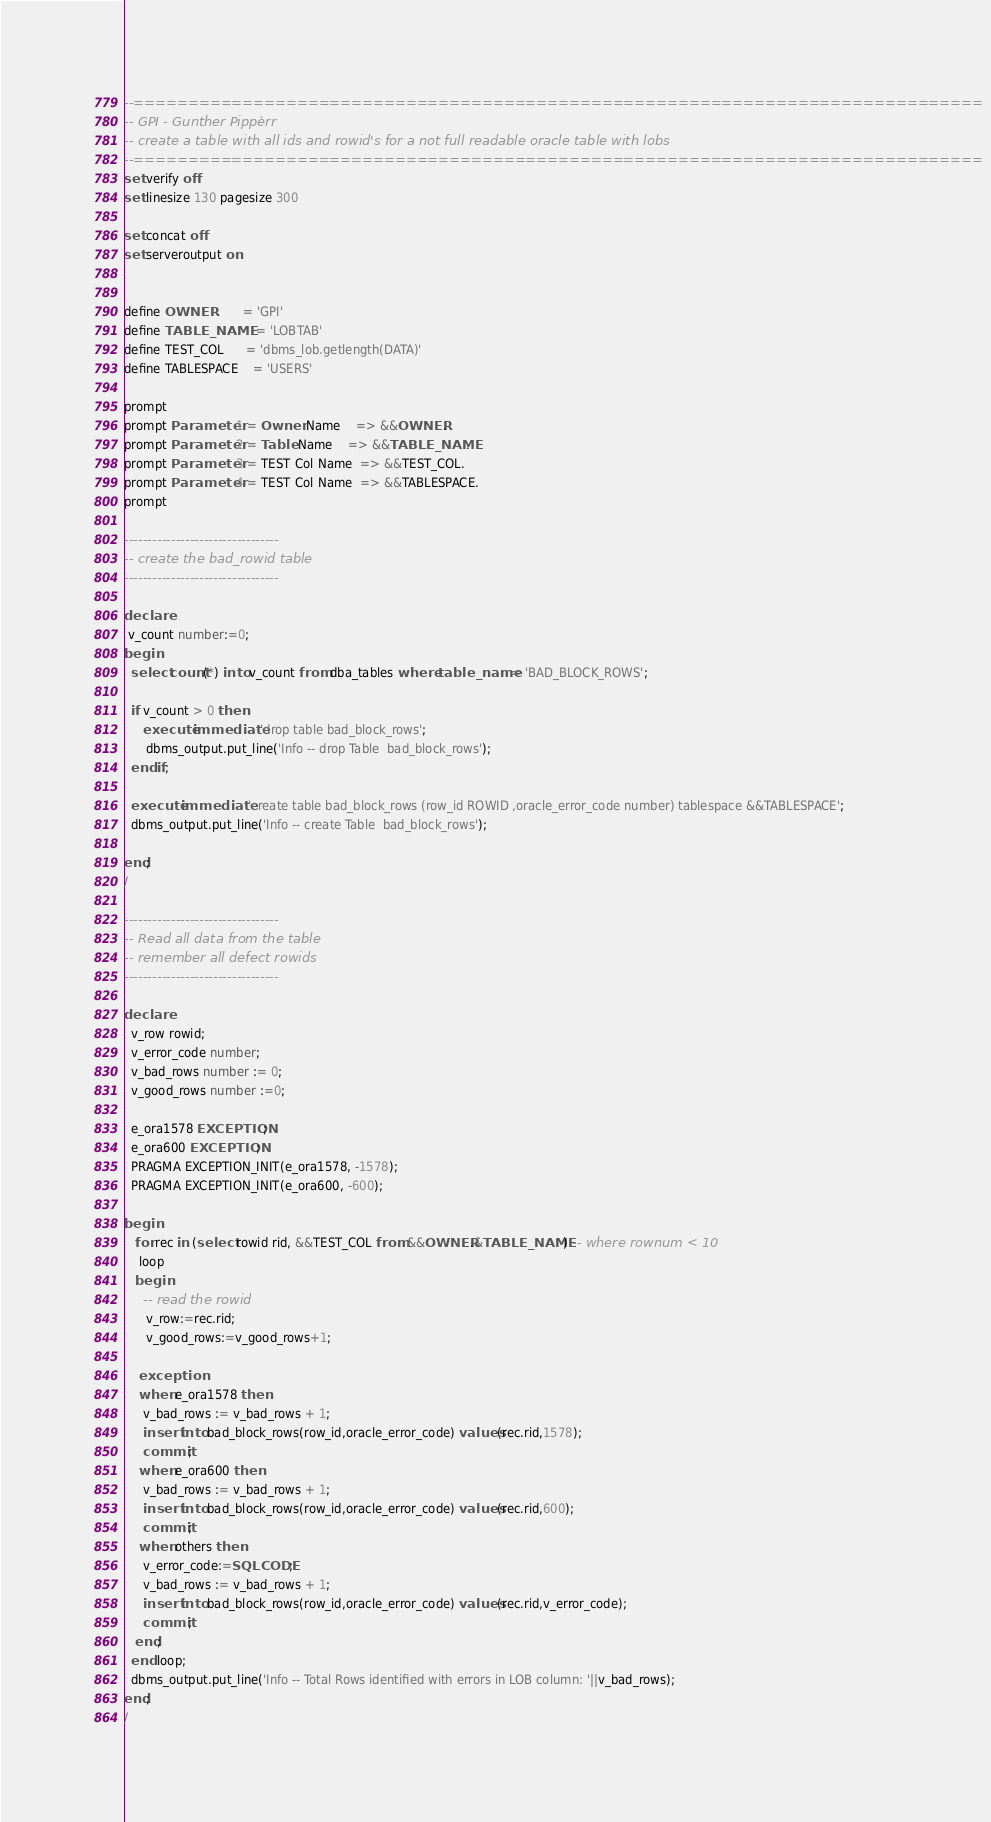Convert code to text. <code><loc_0><loc_0><loc_500><loc_500><_SQL_>--==============================================================================
-- GPI - Gunther Pippèrr
-- create a table with all ids and rowid's for a not full readable oracle table with lobs
--==============================================================================
set verify off
set linesize 130 pagesize 300 

set concat off
set serveroutput on


define OWNER         = 'GPI' 
define TABLE_NAME    = 'LOBTAB' 
define TEST_COL      = 'dbms_lob.getlength(DATA)'
define TABLESPACE    = 'USERS'

prompt
prompt Parameter 1 = Owner  Name    => &&OWNER.
prompt Parameter 2 = Table  Name    => &&TABLE_NAME.
prompt Parameter 3 = TEST Col Name  => &&TEST_COL.
prompt Parameter 4 = TEST Col Name  => &&TABLESPACE.
prompt 

---------------------------------
-- create the bad_rowid table
---------------------------------

declare
 v_count number:=0;
begin
  select count(*) into v_count from dba_tables where table_name = 'BAD_BLOCK_ROWS';
  
  if v_count > 0 then
     execute immediate 'drop table bad_block_rows';
	  dbms_output.put_line('Info -- drop Table  bad_block_rows');
  end if;
  
  execute immediate 'create table bad_block_rows (row_id ROWID ,oracle_error_code number) tablespace &&TABLESPACE';
  dbms_output.put_line('Info -- create Table  bad_block_rows');
  
end;
/

---------------------------------
-- Read all data from the table 
-- remember all defect rowids
---------------------------------

declare
  v_row rowid;
  v_error_code number;
  v_bad_rows number := 0;
  v_good_rows number :=0;
  
  e_ora1578 EXCEPTION;
  e_ora600 EXCEPTION;
  PRAGMA EXCEPTION_INIT(e_ora1578, -1578);
  PRAGMA EXCEPTION_INIT(e_ora600, -600);
  
begin
   for rec in (select rowid rid, &&TEST_COL from &&OWNER.&TABLE_NAME ) -- where rownum < 10
	loop
   begin
     -- read the rowid
	  v_row:=rec.rid;
	  v_good_rows:=v_good_rows+1;
	  
	exception
    when e_ora1578 then
     v_bad_rows := v_bad_rows + 1;
     insert into bad_block_rows(row_id,oracle_error_code) values(rec.rid,1578);
     commit;
    when e_ora600 then
     v_bad_rows := v_bad_rows + 1;
     insert into bad_block_rows(row_id,oracle_error_code) values(rec.rid,600);
     commit;
    when others then
     v_error_code:=SQLCODE;
     v_bad_rows := v_bad_rows + 1;
     insert into bad_block_rows(row_id,oracle_error_code) values(rec.rid,v_error_code);
     commit;   
   end;
  end loop;
  dbms_output.put_line('Info -- Total Rows identified with errors in LOB column: '||v_bad_rows);
end;
/
</code> 